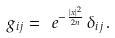<formula> <loc_0><loc_0><loc_500><loc_500>g _ { i j } = \ e ^ { - \frac { | x | ^ { 2 } } { 2 n } } \, \delta _ { i j } \, .</formula> 